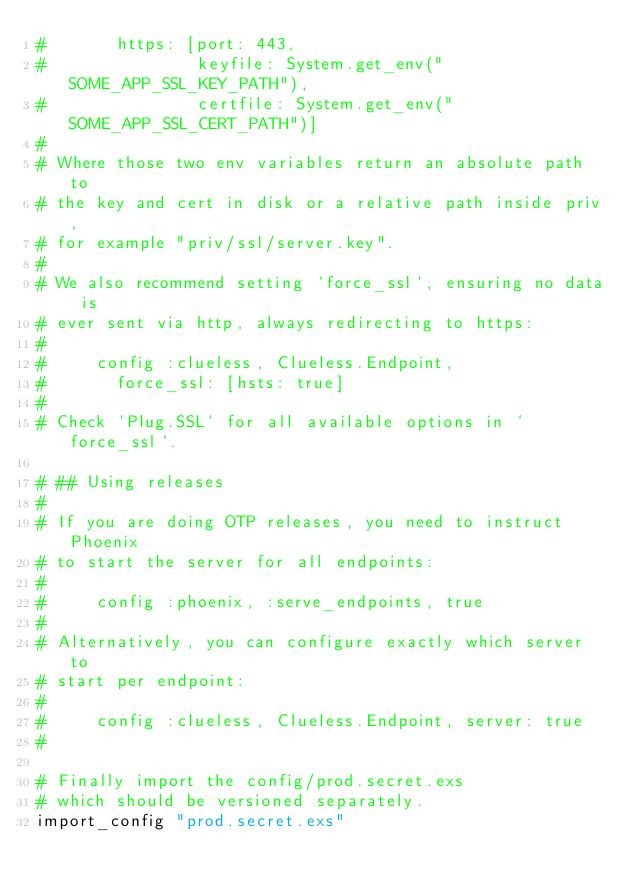<code> <loc_0><loc_0><loc_500><loc_500><_Elixir_>#       https: [port: 443,
#               keyfile: System.get_env("SOME_APP_SSL_KEY_PATH"),
#               certfile: System.get_env("SOME_APP_SSL_CERT_PATH")]
#
# Where those two env variables return an absolute path to
# the key and cert in disk or a relative path inside priv,
# for example "priv/ssl/server.key".
#
# We also recommend setting `force_ssl`, ensuring no data is
# ever sent via http, always redirecting to https:
#
#     config :clueless, Clueless.Endpoint,
#       force_ssl: [hsts: true]
#
# Check `Plug.SSL` for all available options in `force_ssl`.

# ## Using releases
#
# If you are doing OTP releases, you need to instruct Phoenix
# to start the server for all endpoints:
#
#     config :phoenix, :serve_endpoints, true
#
# Alternatively, you can configure exactly which server to
# start per endpoint:
#
#     config :clueless, Clueless.Endpoint, server: true
#

# Finally import the config/prod.secret.exs
# which should be versioned separately.
import_config "prod.secret.exs"

</code> 